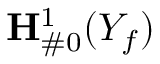Convert formula to latex. <formula><loc_0><loc_0><loc_500><loc_500>{ H } _ { \# 0 } ^ { 1 } ( Y _ { f } )</formula> 